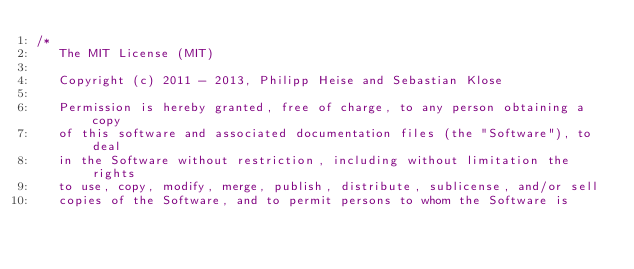<code> <loc_0><loc_0><loc_500><loc_500><_C++_>/*
   The MIT License (MIT)

   Copyright (c) 2011 - 2013, Philipp Heise and Sebastian Klose

   Permission is hereby granted, free of charge, to any person obtaining a copy
   of this software and associated documentation files (the "Software"), to deal
   in the Software without restriction, including without limitation the rights
   to use, copy, modify, merge, publish, distribute, sublicense, and/or sell
   copies of the Software, and to permit persons to whom the Software is</code> 